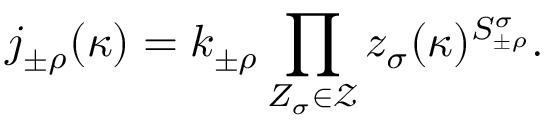<formula> <loc_0><loc_0><loc_500><loc_500>j _ { \pm \rho } ^ { \, } ( \kappa ) = k _ { \pm \rho } \prod _ { Z _ { \sigma } \in \mathcal { Z } } { z } _ { \sigma } ( \kappa ) ^ { { S } _ { \pm \rho } ^ { \sigma } } .</formula> 